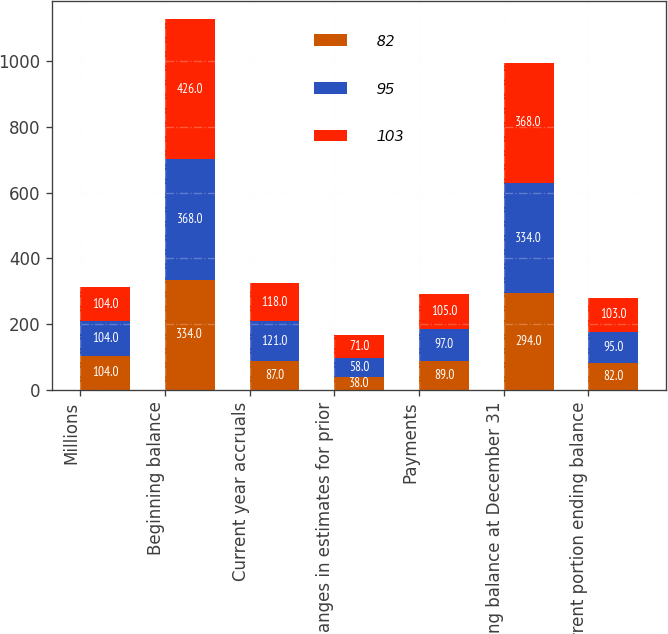<chart> <loc_0><loc_0><loc_500><loc_500><stacked_bar_chart><ecel><fcel>Millions<fcel>Beginning balance<fcel>Current year accruals<fcel>Changes in estimates for prior<fcel>Payments<fcel>Ending balance at December 31<fcel>Current portion ending balance<nl><fcel>82<fcel>104<fcel>334<fcel>87<fcel>38<fcel>89<fcel>294<fcel>82<nl><fcel>95<fcel>104<fcel>368<fcel>121<fcel>58<fcel>97<fcel>334<fcel>95<nl><fcel>103<fcel>104<fcel>426<fcel>118<fcel>71<fcel>105<fcel>368<fcel>103<nl></chart> 